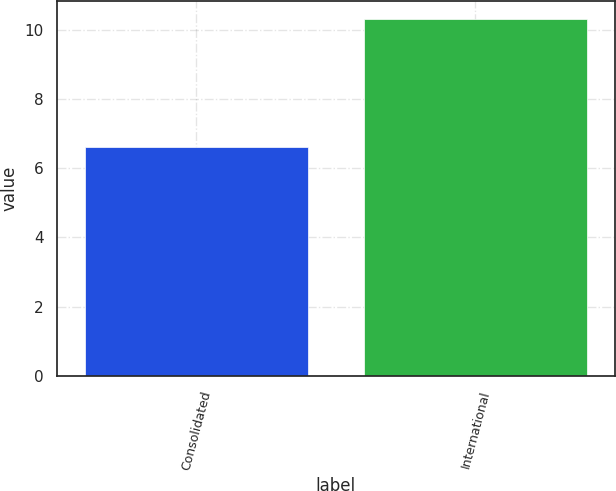Convert chart. <chart><loc_0><loc_0><loc_500><loc_500><bar_chart><fcel>Consolidated<fcel>International<nl><fcel>6.6<fcel>10.3<nl></chart> 